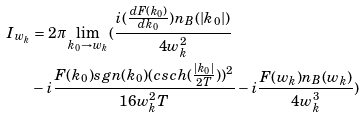<formula> <loc_0><loc_0><loc_500><loc_500>I _ { w _ { k } } & = 2 \pi \lim _ { k _ { 0 } \to w _ { k } } ( \frac { i ( \frac { d F ( k _ { 0 } ) } { d k _ { 0 } } ) n _ { B } ( | k _ { 0 } | ) } { 4 w _ { k } ^ { 2 } } \\ & - i \frac { F ( k _ { 0 } ) s g n ( k _ { 0 } ) ( c s c h ( \frac { | k _ { 0 } | } { 2 T } ) ) ^ { 2 } } { 1 6 w _ { k } ^ { 2 } T } - i \frac { F ( w _ { k } ) n _ { B } ( w _ { k } ) } { 4 w _ { k } ^ { 3 } } )</formula> 